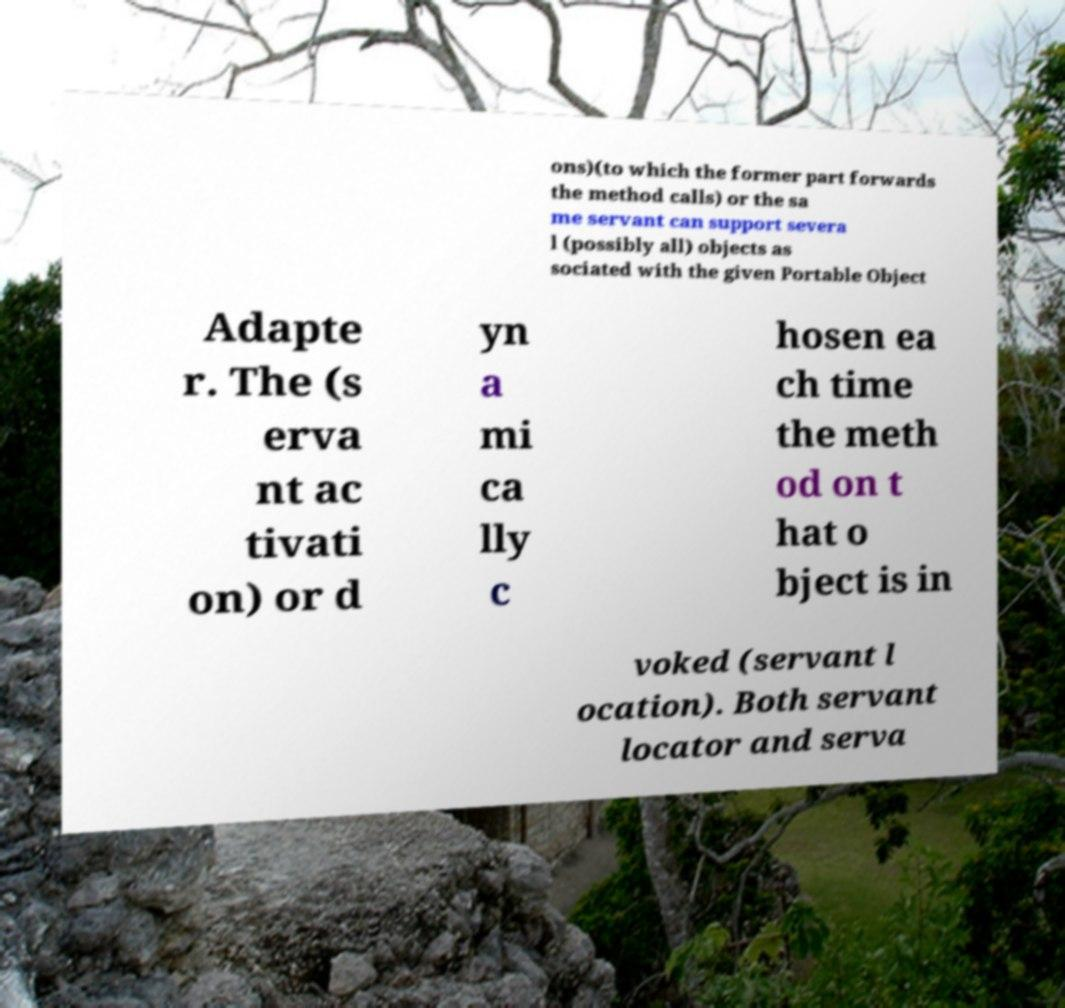Could you extract and type out the text from this image? ons)(to which the former part forwards the method calls) or the sa me servant can support severa l (possibly all) objects as sociated with the given Portable Object Adapte r. The (s erva nt ac tivati on) or d yn a mi ca lly c hosen ea ch time the meth od on t hat o bject is in voked (servant l ocation). Both servant locator and serva 